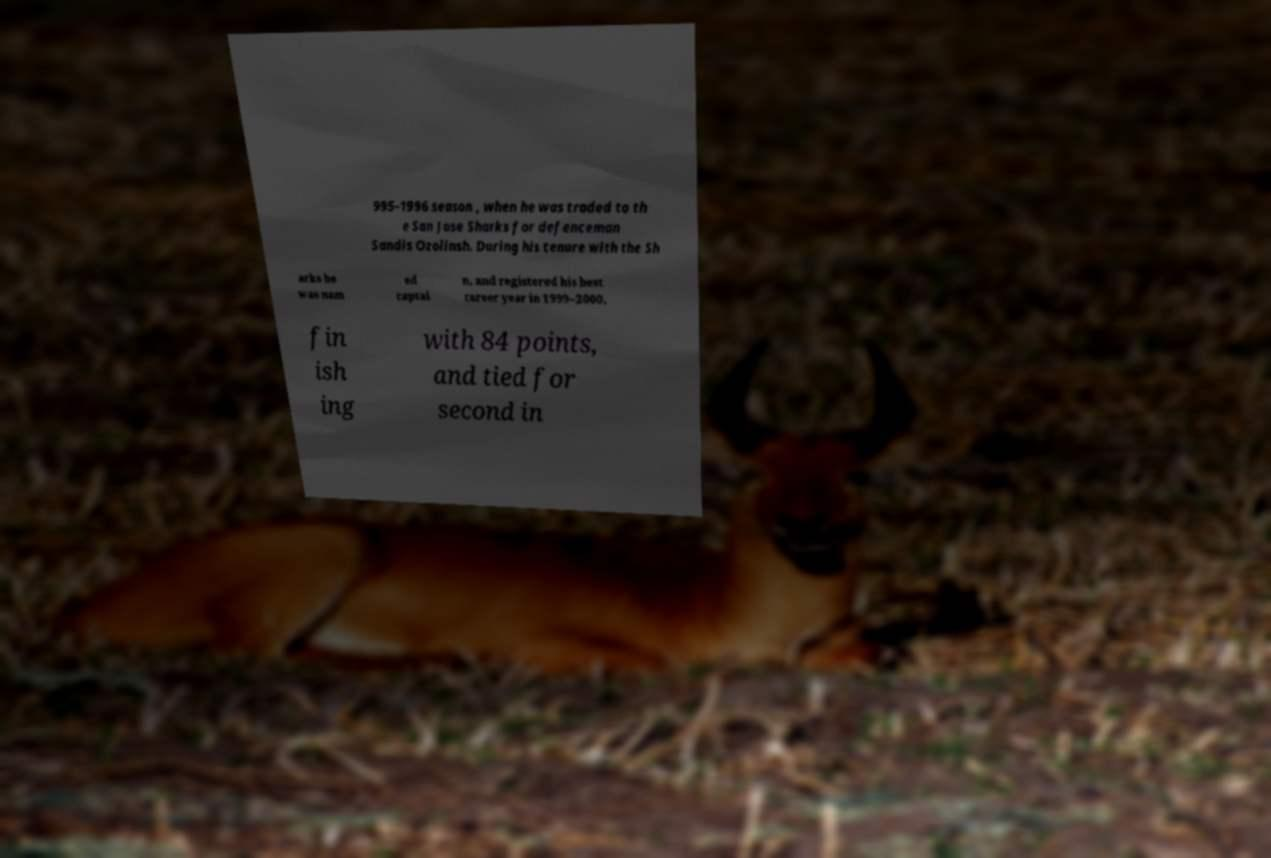I need the written content from this picture converted into text. Can you do that? 995–1996 season , when he was traded to th e San Jose Sharks for defenceman Sandis Ozolinsh. During his tenure with the Sh arks he was nam ed captai n, and registered his best career year in 1999–2000, fin ish ing with 84 points, and tied for second in 